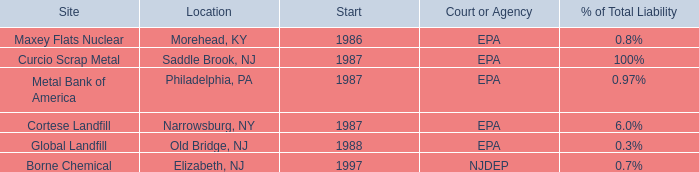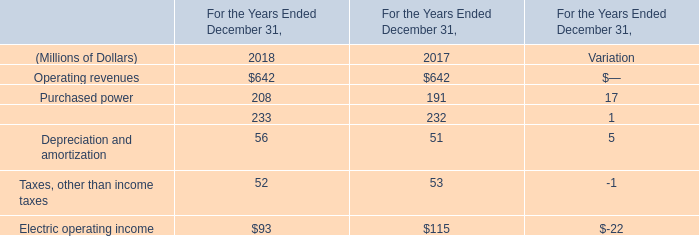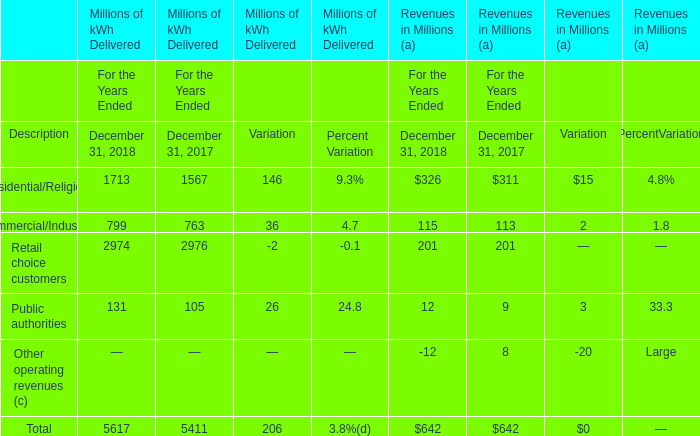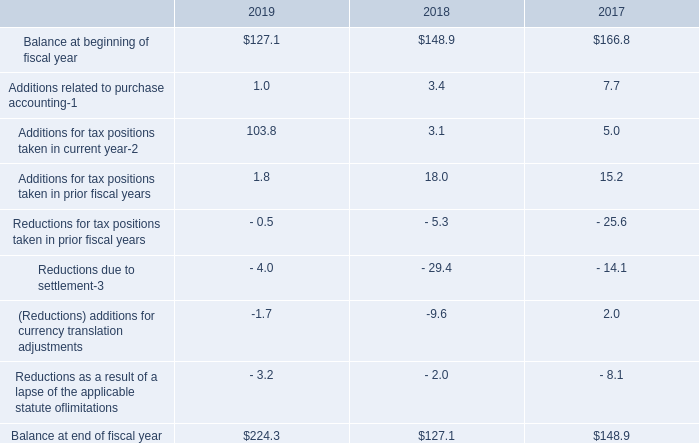what was the percentage change in the gross unrecognized tax benefits from 2017 to 2018 $ 127.1 
Computations: ((127.1 - 148.9) / 148.9)
Answer: -0.14641. 